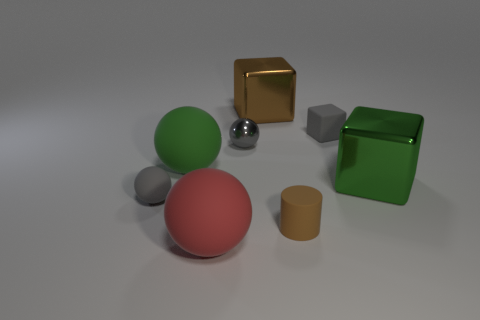Add 2 big brown metallic spheres. How many objects exist? 10 Subtract all blocks. How many objects are left? 5 Subtract all tiny gray spheres. Subtract all green matte things. How many objects are left? 5 Add 4 big green rubber balls. How many big green rubber balls are left? 5 Add 2 brown matte cylinders. How many brown matte cylinders exist? 3 Subtract 0 purple balls. How many objects are left? 8 